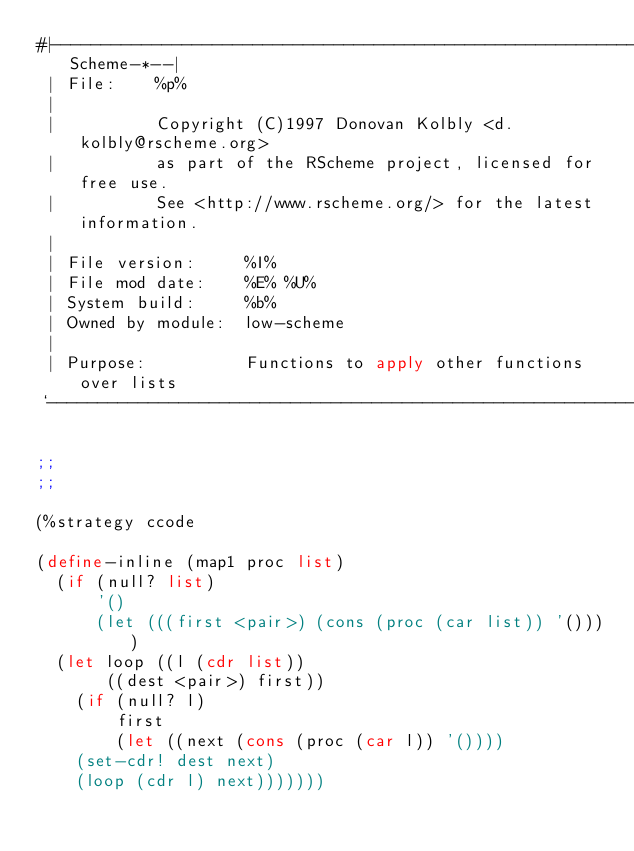<code> <loc_0><loc_0><loc_500><loc_500><_Scheme_>#|------------------------------------------------------------*-Scheme-*--|
 | File:    %p%
 |
 |          Copyright (C)1997 Donovan Kolbly <d.kolbly@rscheme.org>
 |          as part of the RScheme project, licensed for free use.
 |          See <http://www.rscheme.org/> for the latest information.
 |
 | File version:     %I%
 | File mod date:    %E% %U%
 | System build:     %b%
 | Owned by module:  low-scheme
 |
 | Purpose:          Functions to apply other functions over lists
 `------------------------------------------------------------------------|#

;;
;;

(%strategy ccode

(define-inline (map1 proc list)
  (if (null? list)
      '()
      (let (((first <pair>) (cons (proc (car list)) '())))
	(let loop ((l (cdr list))
		   ((dest <pair>) first))
	  (if (null? l)
	      first
	      (let ((next (cons (proc (car l)) '())))
		(set-cdr! dest next)
		(loop (cdr l) next)))))))
</code> 